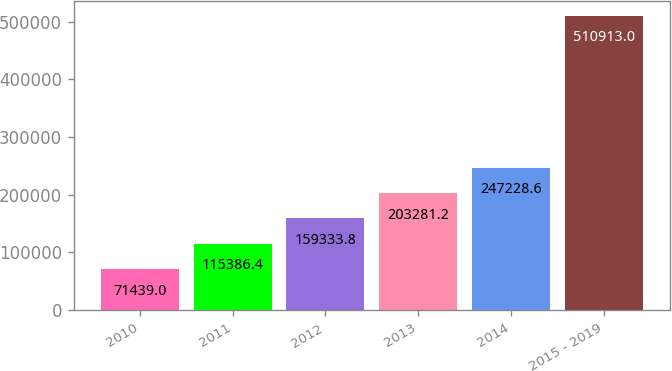Convert chart. <chart><loc_0><loc_0><loc_500><loc_500><bar_chart><fcel>2010<fcel>2011<fcel>2012<fcel>2013<fcel>2014<fcel>2015 - 2019<nl><fcel>71439<fcel>115386<fcel>159334<fcel>203281<fcel>247229<fcel>510913<nl></chart> 